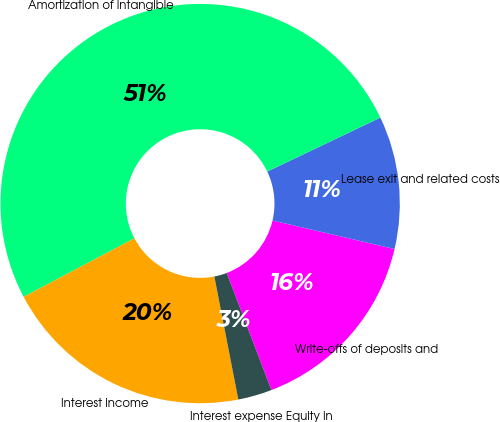<chart> <loc_0><loc_0><loc_500><loc_500><pie_chart><fcel>Write-offs of deposits and<fcel>Lease exit and related costs<fcel>Amortization of intangible<fcel>Interest income<fcel>Interest expense Equity in<nl><fcel>15.53%<fcel>10.74%<fcel>50.65%<fcel>20.32%<fcel>2.75%<nl></chart> 